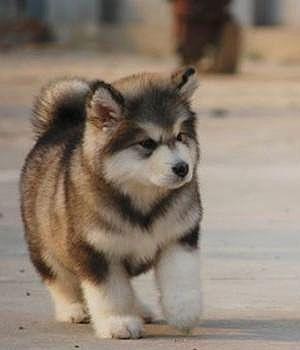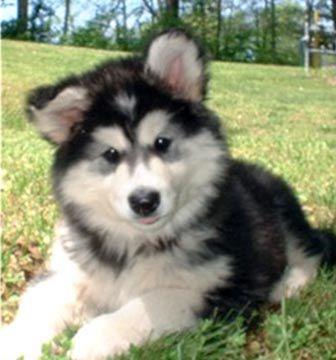The first image is the image on the left, the second image is the image on the right. Examine the images to the left and right. Is the description "One dog has its mouth open." accurate? Answer yes or no. No. 